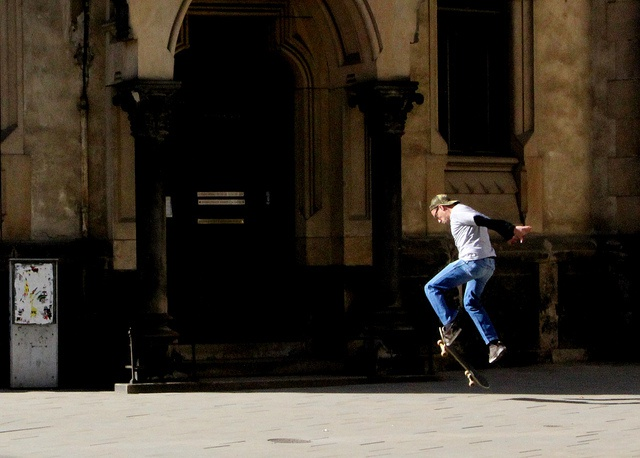Describe the objects in this image and their specific colors. I can see people in black, white, gray, and navy tones and skateboard in black, darkgreen, maroon, and beige tones in this image. 